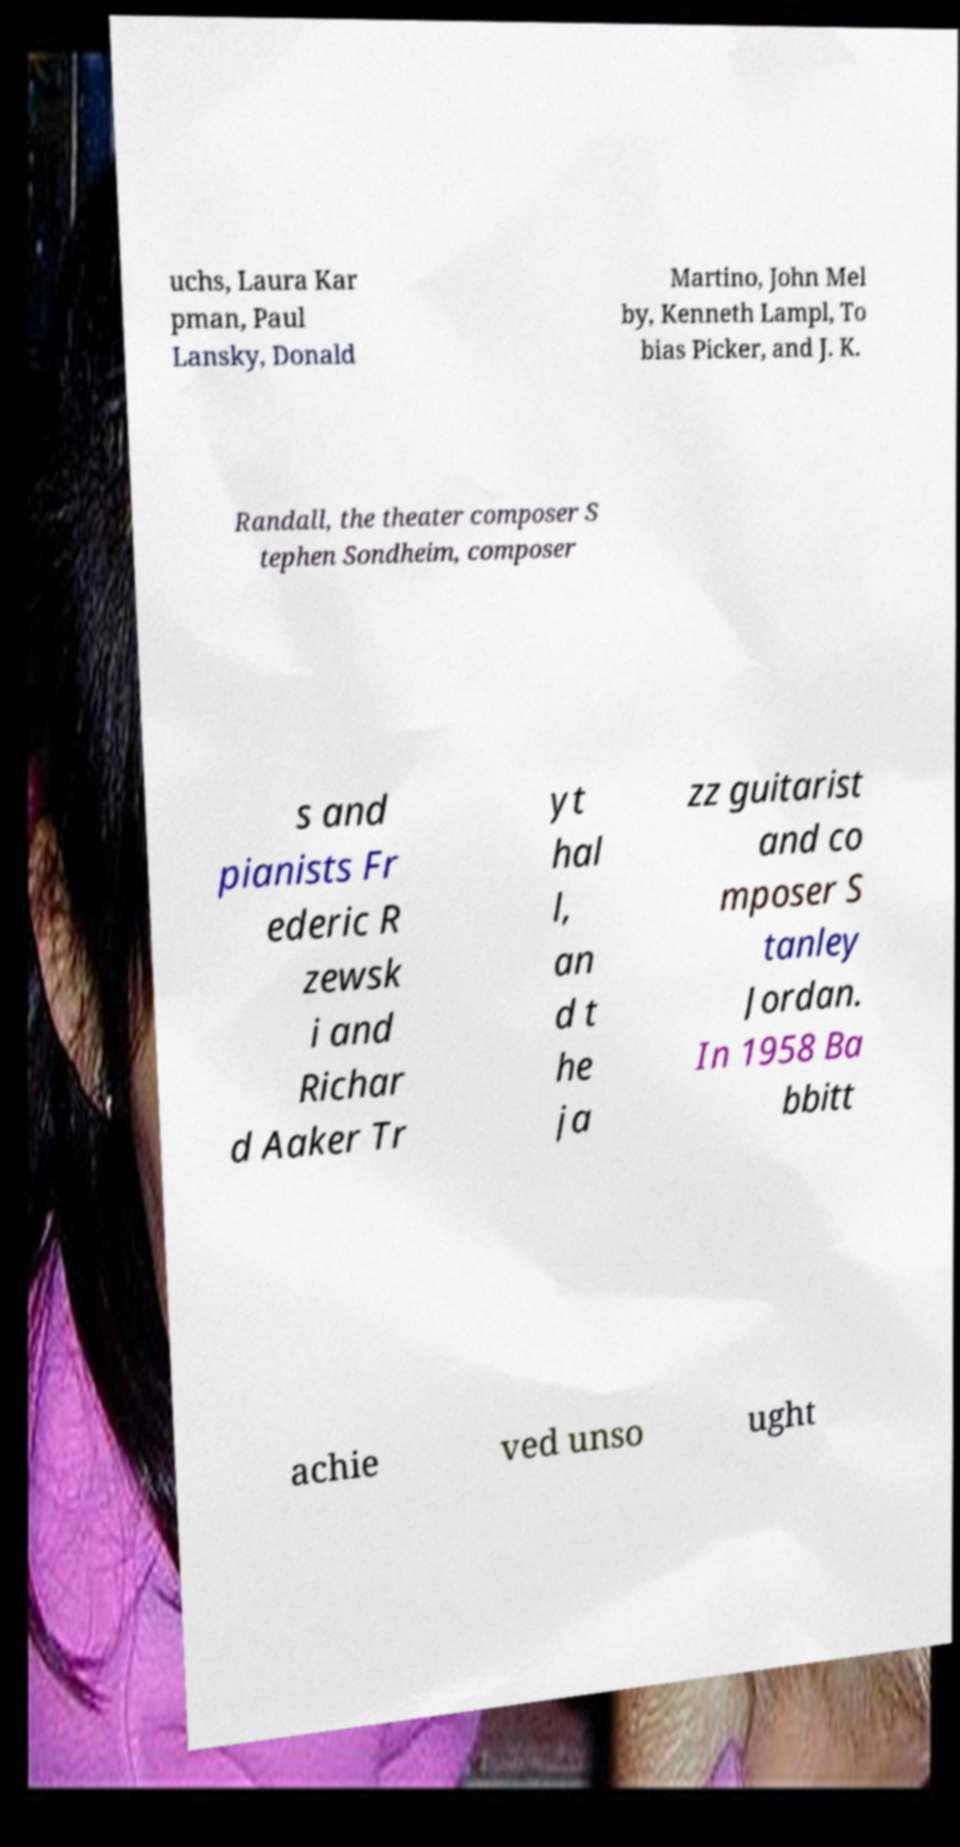I need the written content from this picture converted into text. Can you do that? uchs, Laura Kar pman, Paul Lansky, Donald Martino, John Mel by, Kenneth Lampl, To bias Picker, and J. K. Randall, the theater composer S tephen Sondheim, composer s and pianists Fr ederic R zewsk i and Richar d Aaker Tr yt hal l, an d t he ja zz guitarist and co mposer S tanley Jordan. In 1958 Ba bbitt achie ved unso ught 